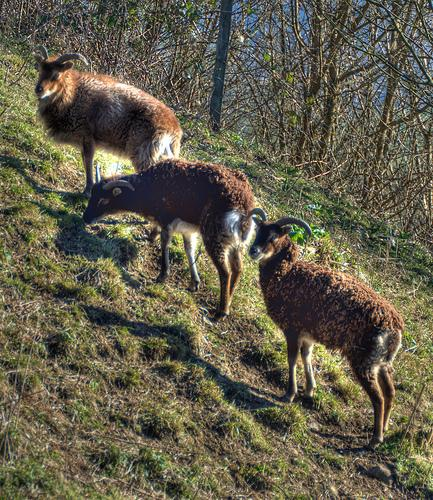Write a sentence about the physical features of rams in the image. Rams in the image show black horns, brown eyes, a black nose, and small furry tails while grazing on grass. Explain the background details found in the image. The background features brown trees with sparse leaves, green plants, and a blue sky visible through the trees. Briefly mention the main subject of the image and describe the setting. The image depicts rams grazing on a hillside, surrounded by brown trees with little foliage and a blue sky overhead. Write a sentence describing the rams in the image and their key features. The rams have black horns, brown and white fur, and small bushy tails, while eating grass on a hill. Describe the main objects in the image along with their major details. There are several rams on a hill featuring black horns, brown and white fur, and small brown tails, surrounded by trees and grass. What type of environment are the rams in and what are they doing? The rams are in a natural environment on a hill with trees, and are grazing on grass and standing together. Mention the key characteristics of the rams in the image. The rams exhibit black horns, brown and white fur, and small tails, with eyes and black hooves on the ground. Describe the main elements of the image, focusing on the presence and action of the rams. A group of rams with characteristic horns and fur are peacefully eating grass on a hillside with trees in the background. Provide a short and simple description of the main scene in the image. A group of rams are grazing on a hillside with trees in the background. Describe the overall atmosphere of the image setting. The setting is tranquil, with rams grazing on a grassy hillside near trees and under a blue sky. 